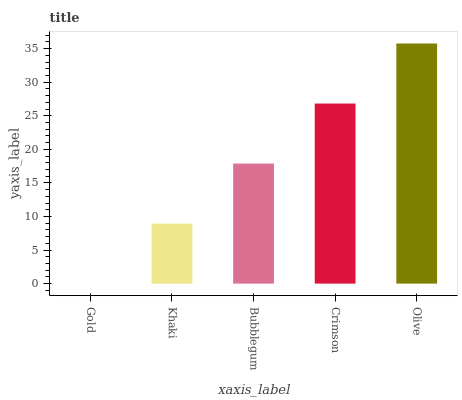Is Gold the minimum?
Answer yes or no. Yes. Is Olive the maximum?
Answer yes or no. Yes. Is Khaki the minimum?
Answer yes or no. No. Is Khaki the maximum?
Answer yes or no. No. Is Khaki greater than Gold?
Answer yes or no. Yes. Is Gold less than Khaki?
Answer yes or no. Yes. Is Gold greater than Khaki?
Answer yes or no. No. Is Khaki less than Gold?
Answer yes or no. No. Is Bubblegum the high median?
Answer yes or no. Yes. Is Bubblegum the low median?
Answer yes or no. Yes. Is Gold the high median?
Answer yes or no. No. Is Olive the low median?
Answer yes or no. No. 